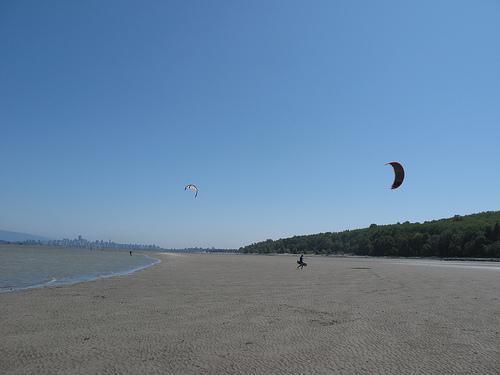How many kites are flying to the left of the person in the foreground?
Give a very brief answer. 1. 